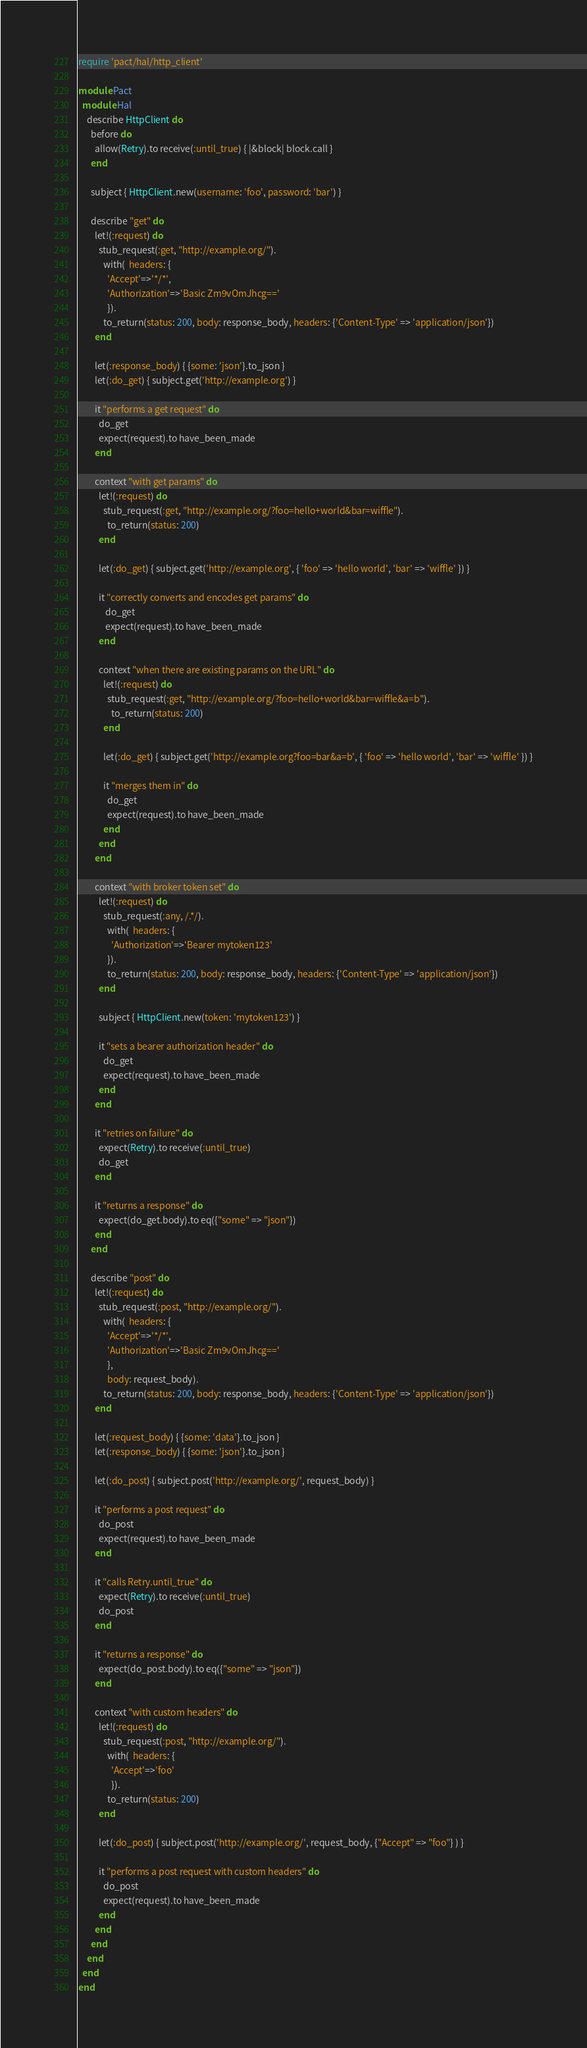<code> <loc_0><loc_0><loc_500><loc_500><_Ruby_>require 'pact/hal/http_client'

module Pact
  module Hal
    describe HttpClient do
      before do
        allow(Retry).to receive(:until_true) { |&block| block.call }
      end

      subject { HttpClient.new(username: 'foo', password: 'bar') }

      describe "get" do
        let!(:request) do
          stub_request(:get, "http://example.org/").
            with(  headers: {
              'Accept'=>'*/*',
              'Authorization'=>'Basic Zm9vOmJhcg=='
              }).
            to_return(status: 200, body: response_body, headers: {'Content-Type' => 'application/json'})
        end

        let(:response_body) { {some: 'json'}.to_json }
        let(:do_get) { subject.get('http://example.org') }

        it "performs a get request" do
          do_get
          expect(request).to have_been_made
        end

        context "with get params" do
          let!(:request) do
            stub_request(:get, "http://example.org/?foo=hello+world&bar=wiffle").
              to_return(status: 200)
          end

          let(:do_get) { subject.get('http://example.org', { 'foo' => 'hello world', 'bar' => 'wiffle' }) }

          it "correctly converts and encodes get params" do
             do_get
             expect(request).to have_been_made
          end

          context "when there are existing params on the URL" do
            let!(:request) do
              stub_request(:get, "http://example.org/?foo=hello+world&bar=wiffle&a=b").
                to_return(status: 200)
            end

            let(:do_get) { subject.get('http://example.org?foo=bar&a=b', { 'foo' => 'hello world', 'bar' => 'wiffle' }) }

            it "merges them in" do
              do_get
              expect(request).to have_been_made
            end
          end
        end

        context "with broker token set" do
          let!(:request) do
            stub_request(:any, /.*/).
              with(  headers: {
                'Authorization'=>'Bearer mytoken123'
              }).
              to_return(status: 200, body: response_body, headers: {'Content-Type' => 'application/json'})
          end

          subject { HttpClient.new(token: 'mytoken123') }

          it "sets a bearer authorization header" do
            do_get
            expect(request).to have_been_made
          end
        end

        it "retries on failure" do
          expect(Retry).to receive(:until_true)
          do_get
        end

        it "returns a response" do
          expect(do_get.body).to eq({"some" => "json"})
        end
      end

      describe "post" do
        let!(:request) do
          stub_request(:post, "http://example.org/").
            with(  headers: {
              'Accept'=>'*/*',
              'Authorization'=>'Basic Zm9vOmJhcg=='
              },
              body: request_body).
            to_return(status: 200, body: response_body, headers: {'Content-Type' => 'application/json'})
        end

        let(:request_body) { {some: 'data'}.to_json }
        let(:response_body) { {some: 'json'}.to_json }

        let(:do_post) { subject.post('http://example.org/', request_body) }

        it "performs a post request" do
          do_post
          expect(request).to have_been_made
        end

        it "calls Retry.until_true" do
          expect(Retry).to receive(:until_true)
          do_post
        end

        it "returns a response" do
          expect(do_post.body).to eq({"some" => "json"})
        end

        context "with custom headers" do
          let!(:request) do
            stub_request(:post, "http://example.org/").
              with(  headers: {
                'Accept'=>'foo'
                }).
              to_return(status: 200)
          end

          let(:do_post) { subject.post('http://example.org/', request_body, {"Accept" => "foo"} ) }

          it "performs a post request with custom headers" do
            do_post
            expect(request).to have_been_made
          end
        end
      end
    end
  end
end
</code> 